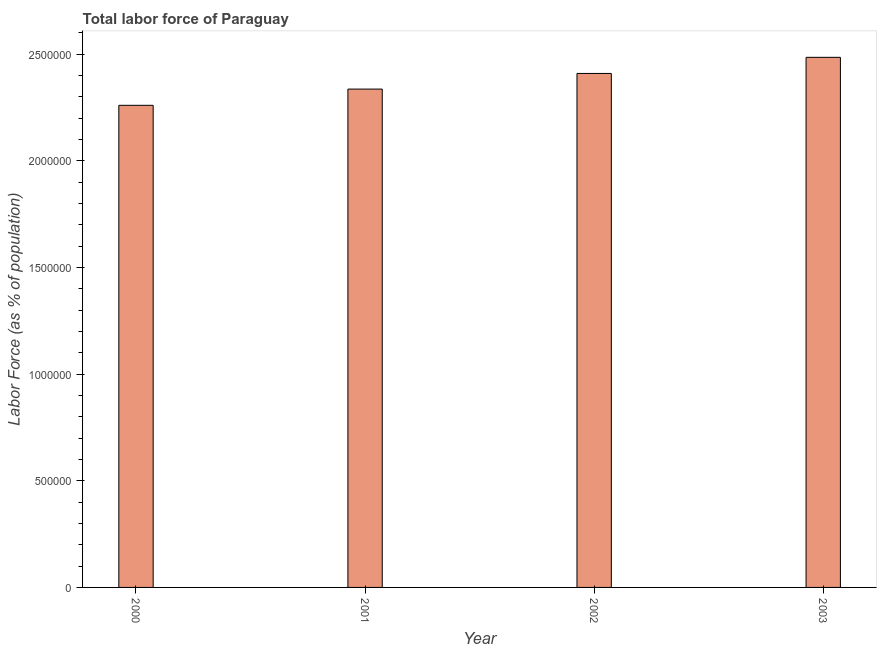Does the graph contain any zero values?
Provide a succinct answer. No. Does the graph contain grids?
Keep it short and to the point. No. What is the title of the graph?
Your response must be concise. Total labor force of Paraguay. What is the label or title of the X-axis?
Your answer should be very brief. Year. What is the label or title of the Y-axis?
Give a very brief answer. Labor Force (as % of population). What is the total labor force in 2001?
Offer a terse response. 2.34e+06. Across all years, what is the maximum total labor force?
Your response must be concise. 2.49e+06. Across all years, what is the minimum total labor force?
Offer a terse response. 2.26e+06. In which year was the total labor force maximum?
Provide a succinct answer. 2003. What is the sum of the total labor force?
Make the answer very short. 9.49e+06. What is the difference between the total labor force in 2000 and 2001?
Ensure brevity in your answer.  -7.61e+04. What is the average total labor force per year?
Your answer should be compact. 2.37e+06. What is the median total labor force?
Make the answer very short. 2.37e+06. In how many years, is the total labor force greater than 2000000 %?
Your response must be concise. 4. Do a majority of the years between 2000 and 2001 (inclusive) have total labor force greater than 2300000 %?
Make the answer very short. No. What is the ratio of the total labor force in 2002 to that in 2003?
Provide a succinct answer. 0.97. Is the difference between the total labor force in 2002 and 2003 greater than the difference between any two years?
Your answer should be very brief. No. What is the difference between the highest and the second highest total labor force?
Ensure brevity in your answer.  7.55e+04. Is the sum of the total labor force in 2001 and 2002 greater than the maximum total labor force across all years?
Offer a very short reply. Yes. What is the difference between the highest and the lowest total labor force?
Provide a succinct answer. 2.25e+05. Are all the bars in the graph horizontal?
Offer a very short reply. No. How many years are there in the graph?
Offer a very short reply. 4. What is the difference between two consecutive major ticks on the Y-axis?
Provide a succinct answer. 5.00e+05. What is the Labor Force (as % of population) of 2000?
Your answer should be very brief. 2.26e+06. What is the Labor Force (as % of population) in 2001?
Provide a short and direct response. 2.34e+06. What is the Labor Force (as % of population) of 2002?
Make the answer very short. 2.41e+06. What is the Labor Force (as % of population) in 2003?
Provide a succinct answer. 2.49e+06. What is the difference between the Labor Force (as % of population) in 2000 and 2001?
Keep it short and to the point. -7.61e+04. What is the difference between the Labor Force (as % of population) in 2000 and 2002?
Make the answer very short. -1.49e+05. What is the difference between the Labor Force (as % of population) in 2000 and 2003?
Your answer should be very brief. -2.25e+05. What is the difference between the Labor Force (as % of population) in 2001 and 2002?
Offer a very short reply. -7.34e+04. What is the difference between the Labor Force (as % of population) in 2001 and 2003?
Provide a succinct answer. -1.49e+05. What is the difference between the Labor Force (as % of population) in 2002 and 2003?
Provide a succinct answer. -7.55e+04. What is the ratio of the Labor Force (as % of population) in 2000 to that in 2002?
Provide a succinct answer. 0.94. What is the ratio of the Labor Force (as % of population) in 2000 to that in 2003?
Your response must be concise. 0.91. What is the ratio of the Labor Force (as % of population) in 2001 to that in 2002?
Offer a very short reply. 0.97. What is the ratio of the Labor Force (as % of population) in 2001 to that in 2003?
Give a very brief answer. 0.94. What is the ratio of the Labor Force (as % of population) in 2002 to that in 2003?
Provide a succinct answer. 0.97. 